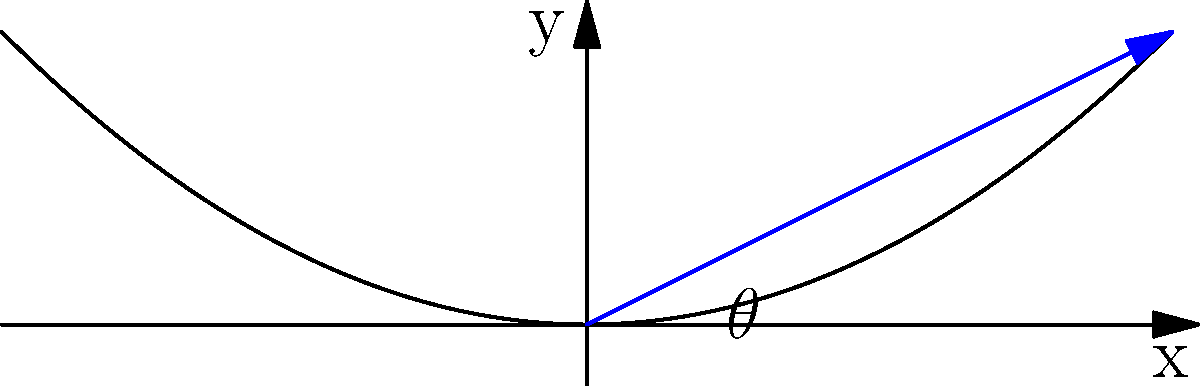In a road construction project, you need to design a curve for a bridge approach. The curve can be modeled by the equation $y = 0.05x^2$, where $x$ and $y$ are in meters. What is the slope angle $\theta$ (in degrees) of the tangent line to this curve at the point (10, 5)? To find the slope angle $\theta$, we need to follow these steps:

1) First, we need to find the derivative of the curve equation:
   $y = 0.05x^2$
   $\frac{dy}{dx} = 0.1x$

2) At the point (10, 5), the slope of the tangent line is:
   $\frac{dy}{dx}|_{x=10} = 0.1 \times 10 = 1$

3) The slope of a line is equal to the tangent of its angle with the x-axis:
   $\tan(\theta) = 1$

4) To find $\theta$, we need to take the inverse tangent (arctan or $\tan^{-1}$):
   $\theta = \tan^{-1}(1)$

5) Using a calculator or standard values, we find:
   $\theta = 45°$

Therefore, the slope angle of the tangent line at the point (10, 5) is 45 degrees.
Answer: 45° 